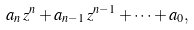Convert formula to latex. <formula><loc_0><loc_0><loc_500><loc_500>a _ { n } \, z ^ { n } + a _ { n - 1 } \, z ^ { n - 1 } + \cdots + a _ { 0 } ,</formula> 